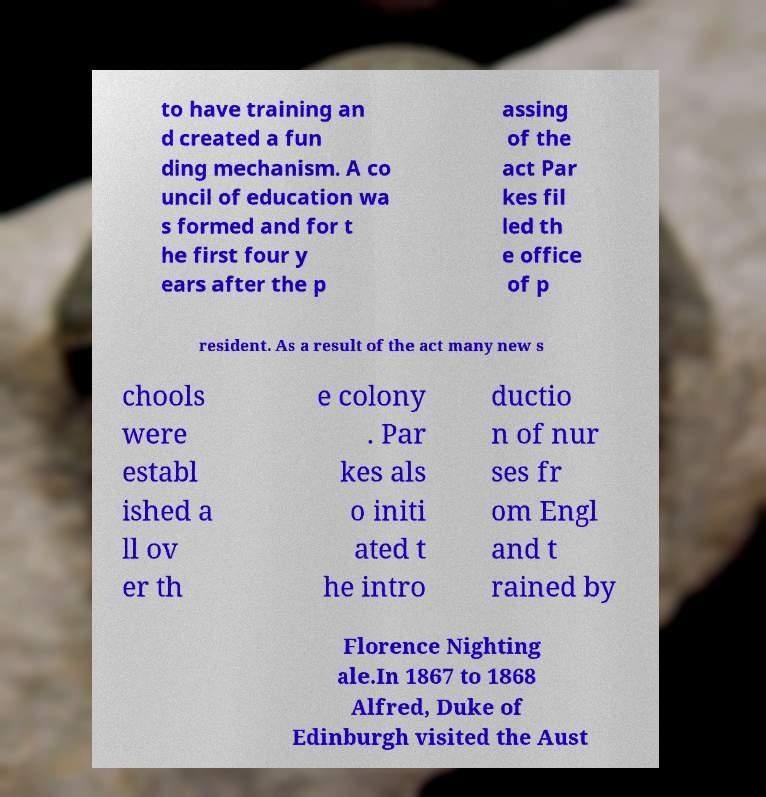Please read and relay the text visible in this image. What does it say? to have training an d created a fun ding mechanism. A co uncil of education wa s formed and for t he first four y ears after the p assing of the act Par kes fil led th e office of p resident. As a result of the act many new s chools were establ ished a ll ov er th e colony . Par kes als o initi ated t he intro ductio n of nur ses fr om Engl and t rained by Florence Nighting ale.In 1867 to 1868 Alfred, Duke of Edinburgh visited the Aust 